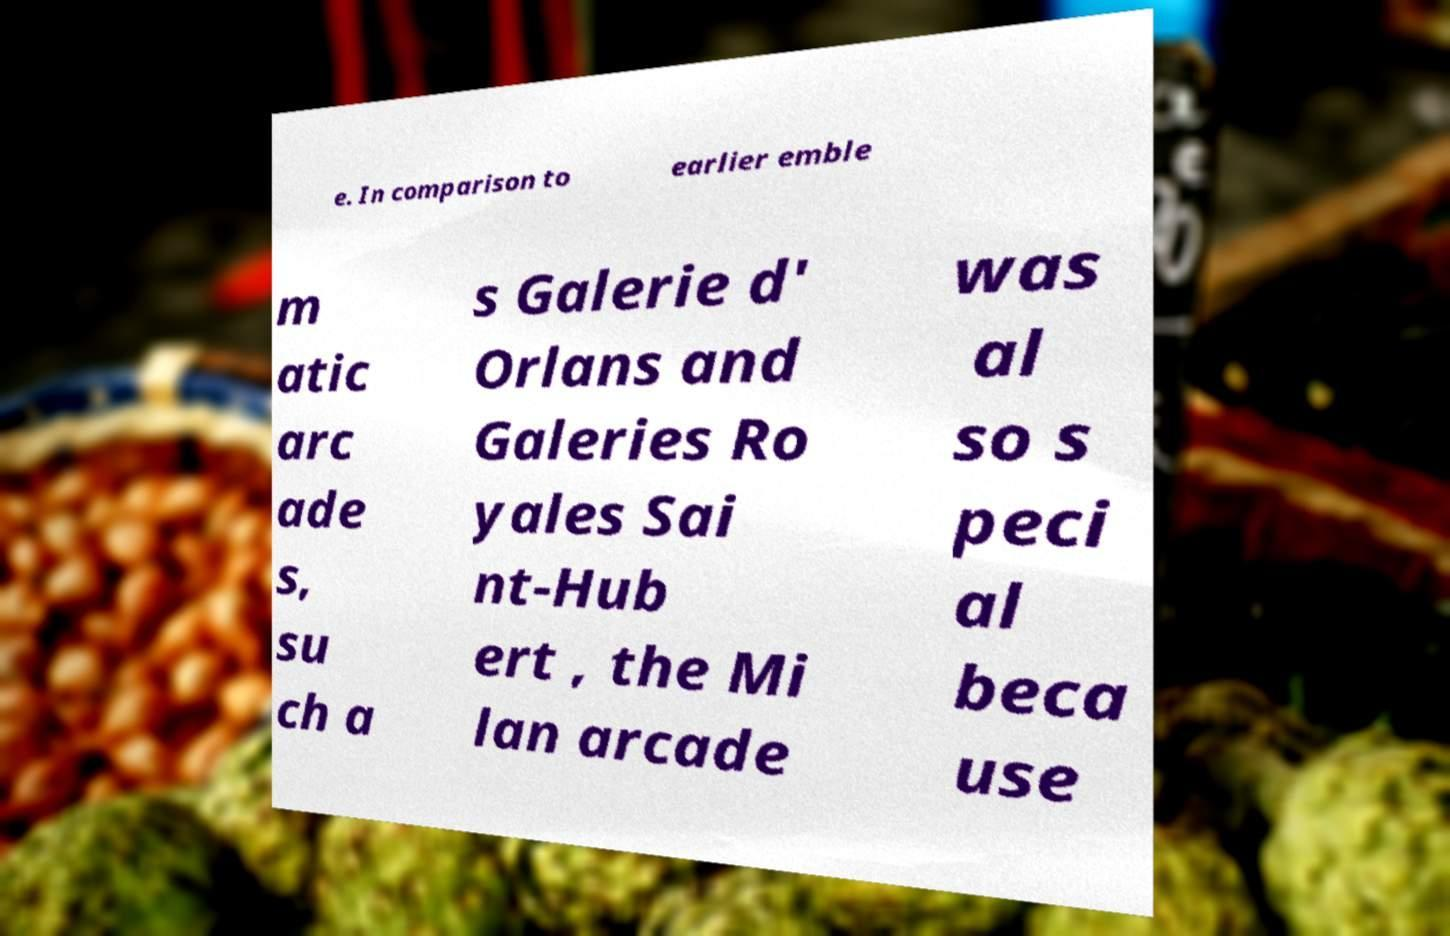There's text embedded in this image that I need extracted. Can you transcribe it verbatim? e. In comparison to earlier emble m atic arc ade s, su ch a s Galerie d' Orlans and Galeries Ro yales Sai nt-Hub ert , the Mi lan arcade was al so s peci al beca use 